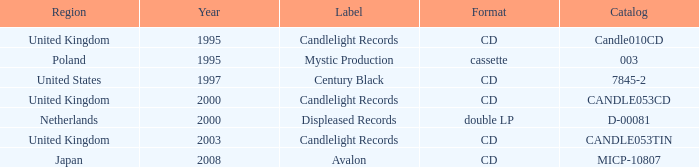What is candlelight records' structure? CD, CD, CD. 